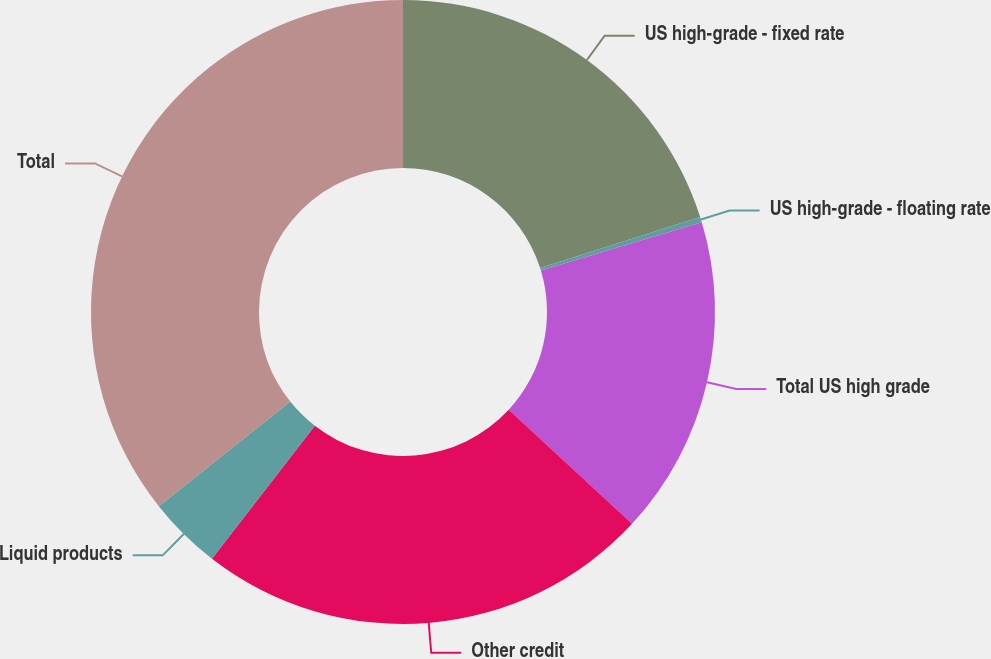Convert chart to OTSL. <chart><loc_0><loc_0><loc_500><loc_500><pie_chart><fcel>US high-grade - fixed rate<fcel>US high-grade - floating rate<fcel>Total US high grade<fcel>Other credit<fcel>Liquid products<fcel>Total<nl><fcel>20.07%<fcel>0.28%<fcel>16.53%<fcel>23.61%<fcel>3.82%<fcel>35.69%<nl></chart> 